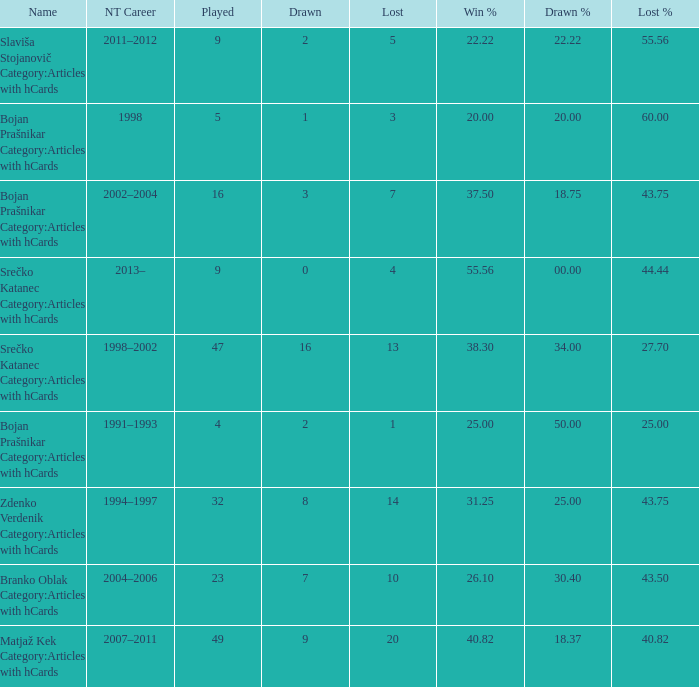How many values for Lost% occur when the value for drawn is 8 and less than 14 lost? 0.0. 